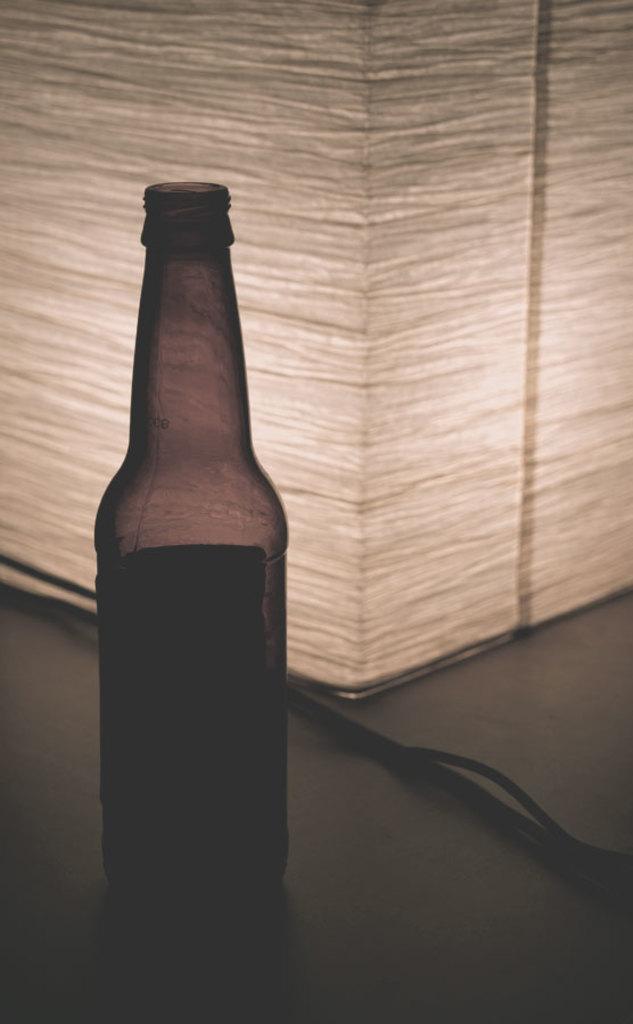Describe this image in one or two sentences. In this image we can see a bottle on a surface. Behind the bottle we can see a wire and an object. 